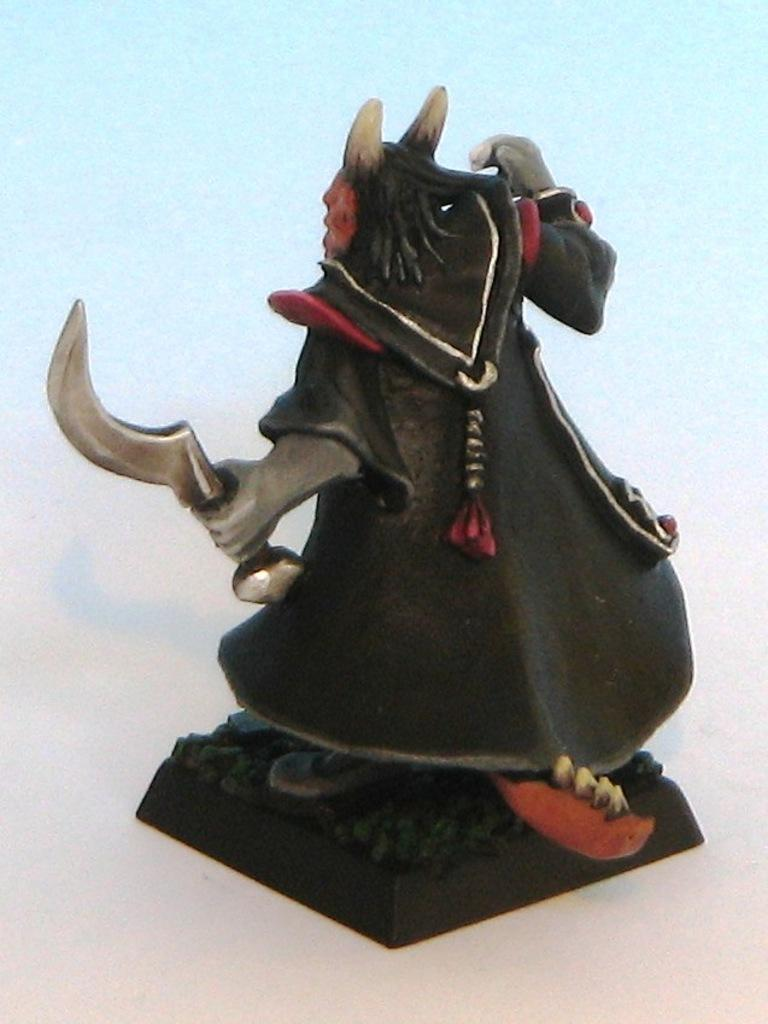What is the main subject of the image? There is a sculpture in the image. Where is the sculpture located? The sculpture is on a platform. What color is the background of the image? The background of the image has a light blue color. What type of wool is used to create the sculpture in the image? There is no wool used in the sculpture in the image; it is likely made of a different material, such as stone or metal. 